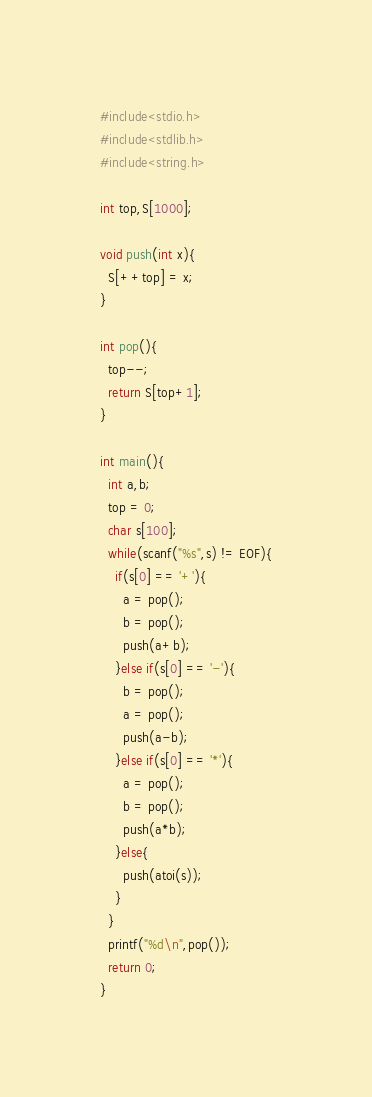<code> <loc_0><loc_0><loc_500><loc_500><_C_>#include<stdio.h>
#include<stdlib.h>
#include<string.h>

int top,S[1000];

void push(int x){
  S[++top] = x;
}

int pop(){
  top--;
  return S[top+1];
}

int main(){
  int a,b;
  top = 0;
  char s[100];
  while(scanf("%s",s) != EOF){
    if(s[0] == '+'){
      a = pop();
      b = pop();
      push(a+b);
    }else if(s[0] == '-'){
      b = pop();
      a = pop();
      push(a-b);
    }else if(s[0] == '*'){
      a = pop();
      b = pop();
      push(a*b);
    }else{
      push(atoi(s));
    }
  }
  printf("%d\n",pop());
  return 0;
}

</code> 